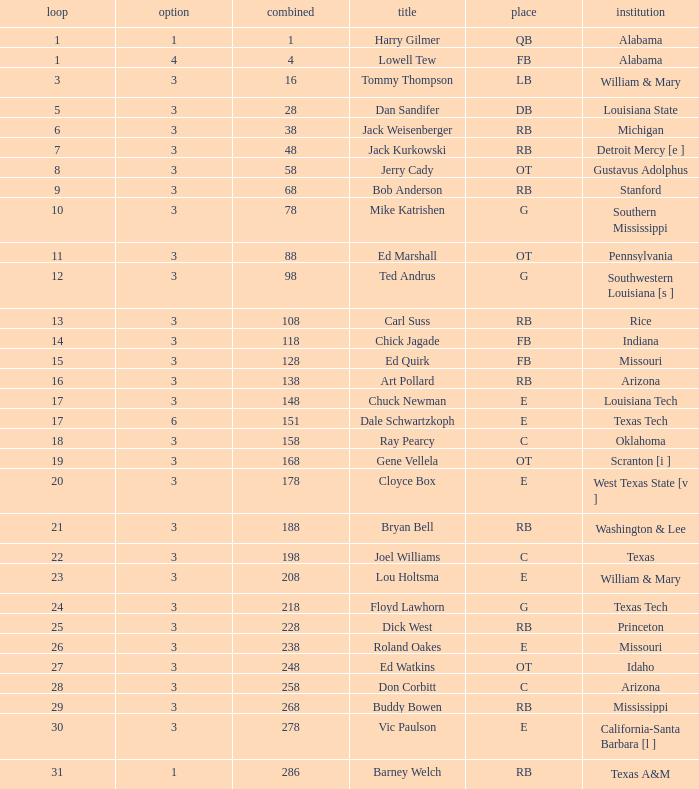Which Overall has a Name of bob anderson, and a Round smaller than 9? None. 